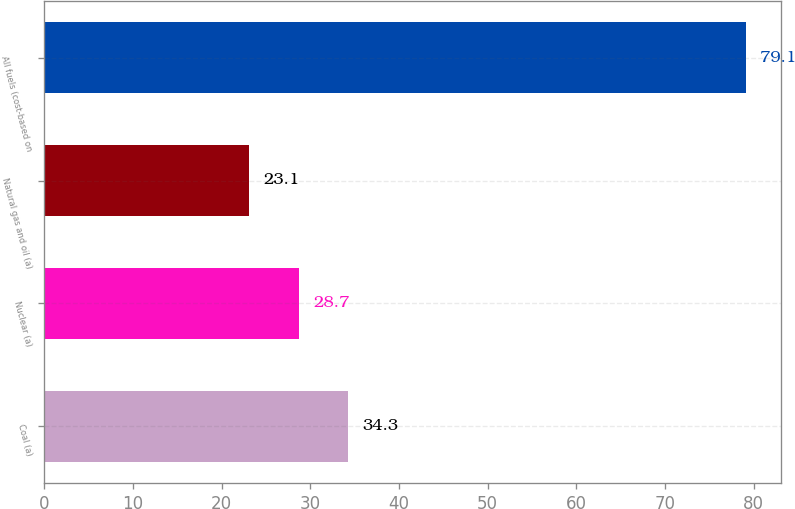Convert chart to OTSL. <chart><loc_0><loc_0><loc_500><loc_500><bar_chart><fcel>Coal (a)<fcel>Nuclear (a)<fcel>Natural gas and oil (a)<fcel>All fuels (cost-based on<nl><fcel>34.3<fcel>28.7<fcel>23.1<fcel>79.1<nl></chart> 